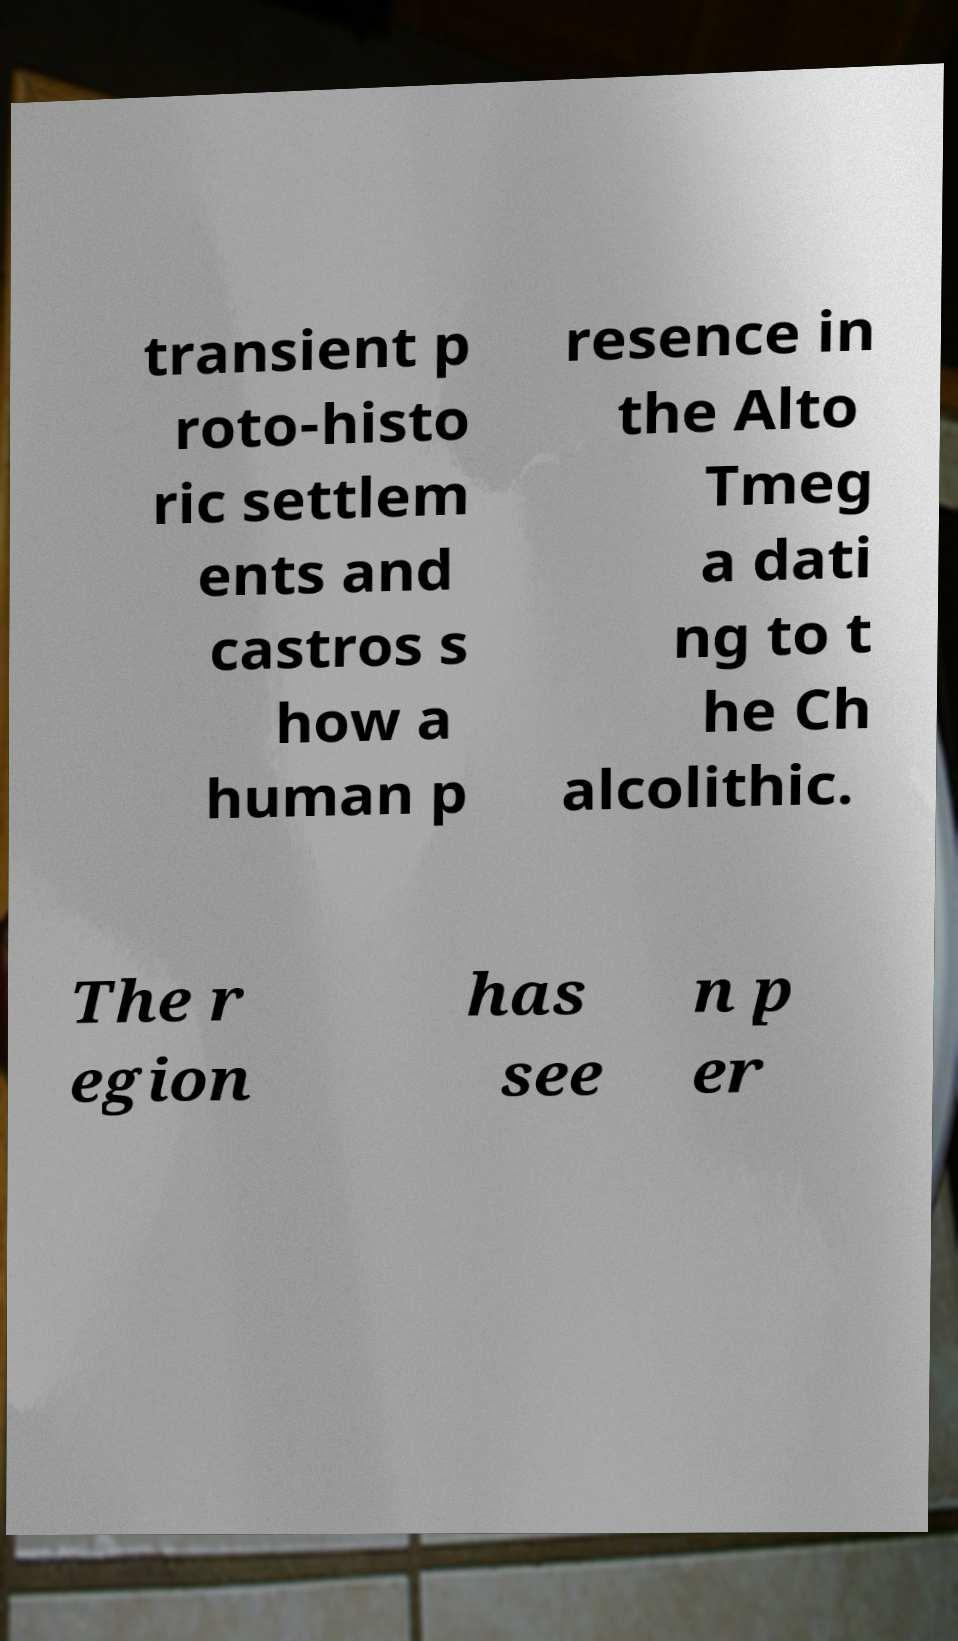For documentation purposes, I need the text within this image transcribed. Could you provide that? transient p roto-histo ric settlem ents and castros s how a human p resence in the Alto Tmeg a dati ng to t he Ch alcolithic. The r egion has see n p er 